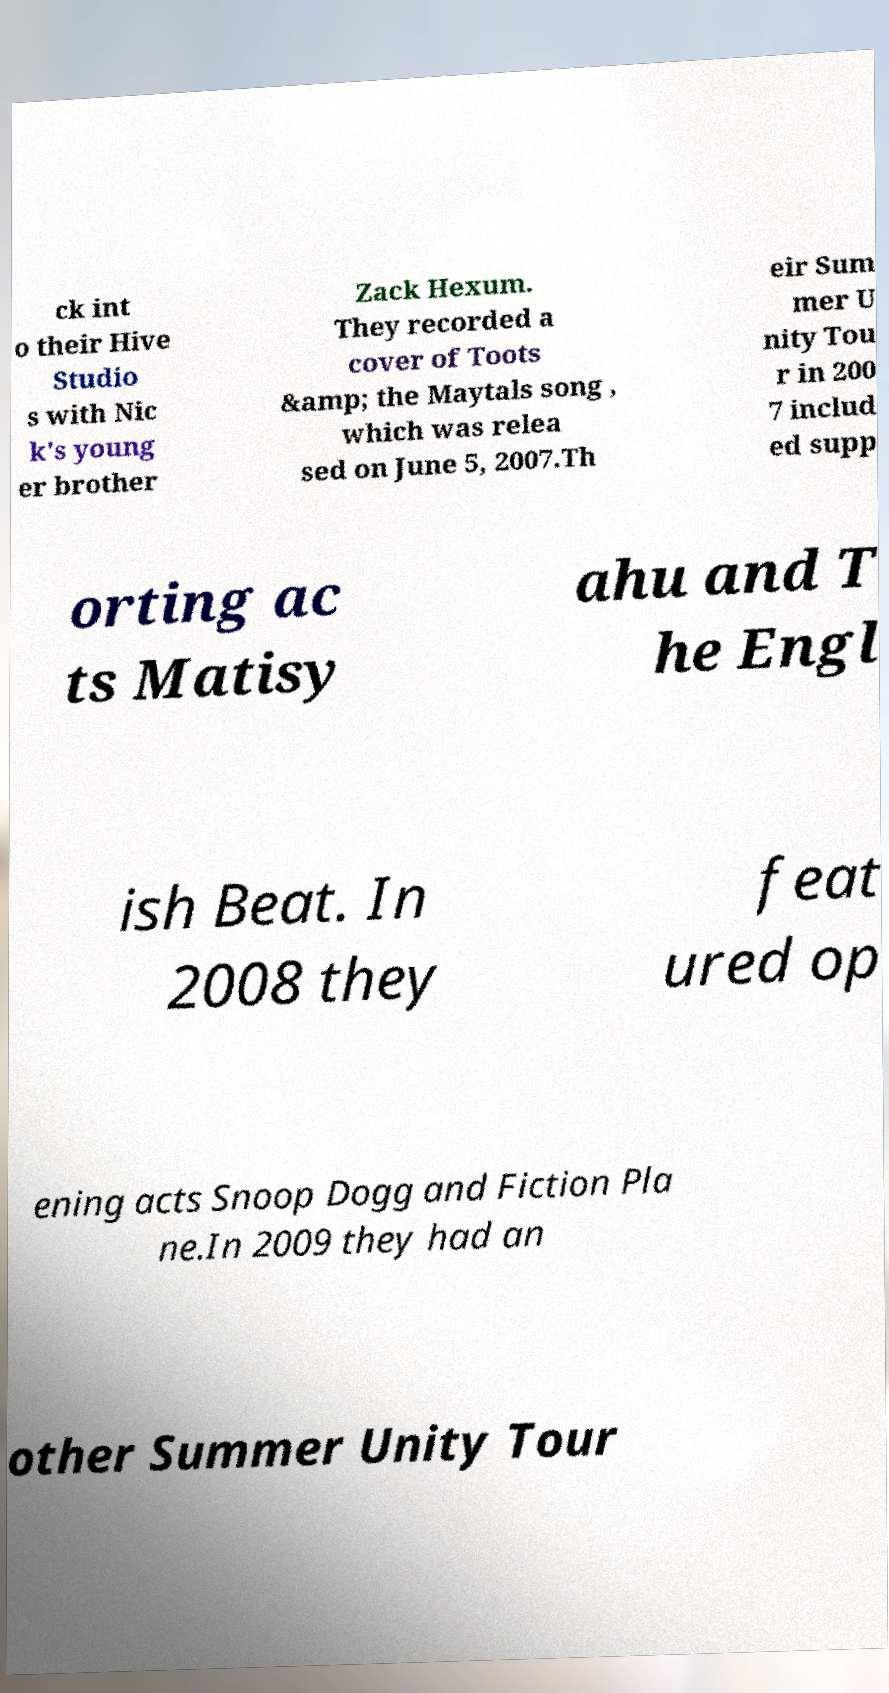Could you assist in decoding the text presented in this image and type it out clearly? ck int o their Hive Studio s with Nic k's young er brother Zack Hexum. They recorded a cover of Toots &amp; the Maytals song , which was relea sed on June 5, 2007.Th eir Sum mer U nity Tou r in 200 7 includ ed supp orting ac ts Matisy ahu and T he Engl ish Beat. In 2008 they feat ured op ening acts Snoop Dogg and Fiction Pla ne.In 2009 they had an other Summer Unity Tour 